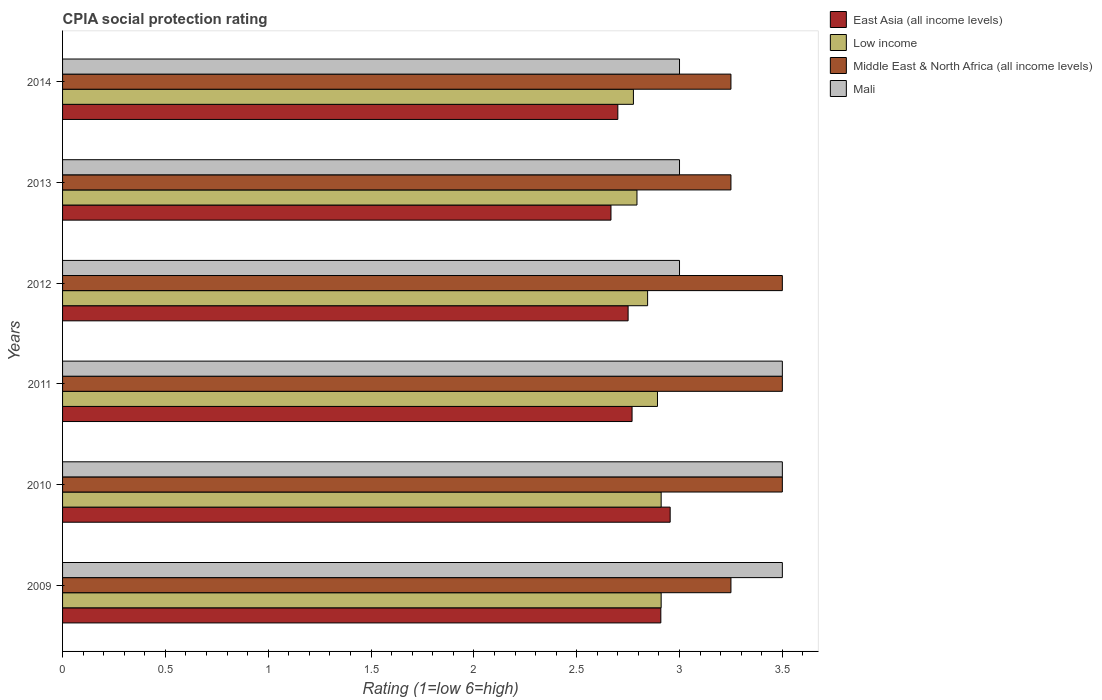How many bars are there on the 5th tick from the top?
Offer a very short reply. 4. How many bars are there on the 2nd tick from the bottom?
Offer a terse response. 4. What is the label of the 5th group of bars from the top?
Provide a short and direct response. 2010. What is the CPIA rating in Middle East & North Africa (all income levels) in 2012?
Provide a short and direct response. 3.5. Across all years, what is the maximum CPIA rating in Mali?
Provide a succinct answer. 3.5. Across all years, what is the minimum CPIA rating in Middle East & North Africa (all income levels)?
Ensure brevity in your answer.  3.25. In which year was the CPIA rating in East Asia (all income levels) maximum?
Provide a succinct answer. 2010. What is the total CPIA rating in Middle East & North Africa (all income levels) in the graph?
Your answer should be very brief. 20.25. What is the difference between the CPIA rating in Low income in 2013 and that in 2014?
Ensure brevity in your answer.  0.02. In the year 2011, what is the difference between the CPIA rating in East Asia (all income levels) and CPIA rating in Middle East & North Africa (all income levels)?
Your response must be concise. -0.73. What is the ratio of the CPIA rating in Middle East & North Africa (all income levels) in 2011 to that in 2013?
Your answer should be very brief. 1.08. Is the CPIA rating in Mali in 2010 less than that in 2013?
Provide a succinct answer. No. Is the difference between the CPIA rating in East Asia (all income levels) in 2010 and 2013 greater than the difference between the CPIA rating in Middle East & North Africa (all income levels) in 2010 and 2013?
Your answer should be very brief. Yes. What is the difference between the highest and the second highest CPIA rating in Mali?
Offer a terse response. 0. In how many years, is the CPIA rating in Low income greater than the average CPIA rating in Low income taken over all years?
Keep it short and to the point. 3. Is the sum of the CPIA rating in Low income in 2010 and 2014 greater than the maximum CPIA rating in Middle East & North Africa (all income levels) across all years?
Keep it short and to the point. Yes. Is it the case that in every year, the sum of the CPIA rating in Low income and CPIA rating in Middle East & North Africa (all income levels) is greater than the sum of CPIA rating in Mali and CPIA rating in East Asia (all income levels)?
Your answer should be compact. No. What does the 2nd bar from the top in 2010 represents?
Your answer should be very brief. Middle East & North Africa (all income levels). What does the 3rd bar from the bottom in 2009 represents?
Provide a succinct answer. Middle East & North Africa (all income levels). How many years are there in the graph?
Provide a succinct answer. 6. What is the difference between two consecutive major ticks on the X-axis?
Offer a very short reply. 0.5. Are the values on the major ticks of X-axis written in scientific E-notation?
Keep it short and to the point. No. Does the graph contain grids?
Your response must be concise. No. Where does the legend appear in the graph?
Offer a terse response. Top right. How are the legend labels stacked?
Offer a very short reply. Vertical. What is the title of the graph?
Provide a short and direct response. CPIA social protection rating. Does "Belgium" appear as one of the legend labels in the graph?
Ensure brevity in your answer.  No. What is the label or title of the X-axis?
Offer a terse response. Rating (1=low 6=high). What is the Rating (1=low 6=high) of East Asia (all income levels) in 2009?
Your answer should be compact. 2.91. What is the Rating (1=low 6=high) of Low income in 2009?
Ensure brevity in your answer.  2.91. What is the Rating (1=low 6=high) of East Asia (all income levels) in 2010?
Give a very brief answer. 2.95. What is the Rating (1=low 6=high) in Low income in 2010?
Your answer should be very brief. 2.91. What is the Rating (1=low 6=high) in Middle East & North Africa (all income levels) in 2010?
Provide a short and direct response. 3.5. What is the Rating (1=low 6=high) in Mali in 2010?
Provide a succinct answer. 3.5. What is the Rating (1=low 6=high) in East Asia (all income levels) in 2011?
Your answer should be very brief. 2.77. What is the Rating (1=low 6=high) in Low income in 2011?
Ensure brevity in your answer.  2.89. What is the Rating (1=low 6=high) of East Asia (all income levels) in 2012?
Give a very brief answer. 2.75. What is the Rating (1=low 6=high) of Low income in 2012?
Give a very brief answer. 2.84. What is the Rating (1=low 6=high) in East Asia (all income levels) in 2013?
Make the answer very short. 2.67. What is the Rating (1=low 6=high) of Low income in 2013?
Keep it short and to the point. 2.79. What is the Rating (1=low 6=high) of East Asia (all income levels) in 2014?
Offer a very short reply. 2.7. What is the Rating (1=low 6=high) in Low income in 2014?
Ensure brevity in your answer.  2.78. What is the Rating (1=low 6=high) of Middle East & North Africa (all income levels) in 2014?
Your response must be concise. 3.25. What is the Rating (1=low 6=high) in Mali in 2014?
Offer a terse response. 3. Across all years, what is the maximum Rating (1=low 6=high) of East Asia (all income levels)?
Provide a short and direct response. 2.95. Across all years, what is the maximum Rating (1=low 6=high) in Low income?
Your answer should be compact. 2.91. Across all years, what is the maximum Rating (1=low 6=high) in Mali?
Ensure brevity in your answer.  3.5. Across all years, what is the minimum Rating (1=low 6=high) of East Asia (all income levels)?
Provide a succinct answer. 2.67. Across all years, what is the minimum Rating (1=low 6=high) of Low income?
Your answer should be very brief. 2.78. What is the total Rating (1=low 6=high) of East Asia (all income levels) in the graph?
Keep it short and to the point. 16.75. What is the total Rating (1=low 6=high) in Low income in the graph?
Keep it short and to the point. 17.13. What is the total Rating (1=low 6=high) in Middle East & North Africa (all income levels) in the graph?
Your answer should be compact. 20.25. What is the difference between the Rating (1=low 6=high) in East Asia (all income levels) in 2009 and that in 2010?
Provide a short and direct response. -0.05. What is the difference between the Rating (1=low 6=high) of Low income in 2009 and that in 2010?
Offer a very short reply. 0. What is the difference between the Rating (1=low 6=high) in East Asia (all income levels) in 2009 and that in 2011?
Your answer should be very brief. 0.14. What is the difference between the Rating (1=low 6=high) of Low income in 2009 and that in 2011?
Ensure brevity in your answer.  0.02. What is the difference between the Rating (1=low 6=high) of East Asia (all income levels) in 2009 and that in 2012?
Provide a short and direct response. 0.16. What is the difference between the Rating (1=low 6=high) of Low income in 2009 and that in 2012?
Your answer should be very brief. 0.07. What is the difference between the Rating (1=low 6=high) of Mali in 2009 and that in 2012?
Offer a terse response. 0.5. What is the difference between the Rating (1=low 6=high) in East Asia (all income levels) in 2009 and that in 2013?
Keep it short and to the point. 0.24. What is the difference between the Rating (1=low 6=high) in Low income in 2009 and that in 2013?
Ensure brevity in your answer.  0.12. What is the difference between the Rating (1=low 6=high) in East Asia (all income levels) in 2009 and that in 2014?
Ensure brevity in your answer.  0.21. What is the difference between the Rating (1=low 6=high) in Low income in 2009 and that in 2014?
Your answer should be very brief. 0.13. What is the difference between the Rating (1=low 6=high) in Middle East & North Africa (all income levels) in 2009 and that in 2014?
Your answer should be very brief. 0. What is the difference between the Rating (1=low 6=high) of East Asia (all income levels) in 2010 and that in 2011?
Offer a terse response. 0.19. What is the difference between the Rating (1=low 6=high) in Low income in 2010 and that in 2011?
Keep it short and to the point. 0.02. What is the difference between the Rating (1=low 6=high) of East Asia (all income levels) in 2010 and that in 2012?
Give a very brief answer. 0.2. What is the difference between the Rating (1=low 6=high) in Low income in 2010 and that in 2012?
Your answer should be very brief. 0.07. What is the difference between the Rating (1=low 6=high) in Mali in 2010 and that in 2012?
Provide a short and direct response. 0.5. What is the difference between the Rating (1=low 6=high) in East Asia (all income levels) in 2010 and that in 2013?
Give a very brief answer. 0.29. What is the difference between the Rating (1=low 6=high) of Low income in 2010 and that in 2013?
Offer a terse response. 0.12. What is the difference between the Rating (1=low 6=high) of Mali in 2010 and that in 2013?
Give a very brief answer. 0.5. What is the difference between the Rating (1=low 6=high) of East Asia (all income levels) in 2010 and that in 2014?
Offer a very short reply. 0.25. What is the difference between the Rating (1=low 6=high) of Low income in 2010 and that in 2014?
Provide a short and direct response. 0.13. What is the difference between the Rating (1=low 6=high) in East Asia (all income levels) in 2011 and that in 2012?
Provide a succinct answer. 0.02. What is the difference between the Rating (1=low 6=high) of Low income in 2011 and that in 2012?
Your answer should be compact. 0.05. What is the difference between the Rating (1=low 6=high) of Middle East & North Africa (all income levels) in 2011 and that in 2012?
Offer a terse response. 0. What is the difference between the Rating (1=low 6=high) of East Asia (all income levels) in 2011 and that in 2013?
Provide a short and direct response. 0.1. What is the difference between the Rating (1=low 6=high) in Low income in 2011 and that in 2013?
Provide a short and direct response. 0.1. What is the difference between the Rating (1=low 6=high) in Mali in 2011 and that in 2013?
Your answer should be compact. 0.5. What is the difference between the Rating (1=low 6=high) of East Asia (all income levels) in 2011 and that in 2014?
Keep it short and to the point. 0.07. What is the difference between the Rating (1=low 6=high) of Low income in 2011 and that in 2014?
Provide a succinct answer. 0.12. What is the difference between the Rating (1=low 6=high) of East Asia (all income levels) in 2012 and that in 2013?
Make the answer very short. 0.08. What is the difference between the Rating (1=low 6=high) of Low income in 2012 and that in 2013?
Your answer should be very brief. 0.05. What is the difference between the Rating (1=low 6=high) in Middle East & North Africa (all income levels) in 2012 and that in 2013?
Offer a very short reply. 0.25. What is the difference between the Rating (1=low 6=high) in Mali in 2012 and that in 2013?
Your answer should be compact. 0. What is the difference between the Rating (1=low 6=high) of Low income in 2012 and that in 2014?
Your answer should be very brief. 0.07. What is the difference between the Rating (1=low 6=high) of Middle East & North Africa (all income levels) in 2012 and that in 2014?
Make the answer very short. 0.25. What is the difference between the Rating (1=low 6=high) in Mali in 2012 and that in 2014?
Ensure brevity in your answer.  0. What is the difference between the Rating (1=low 6=high) in East Asia (all income levels) in 2013 and that in 2014?
Keep it short and to the point. -0.03. What is the difference between the Rating (1=low 6=high) in Low income in 2013 and that in 2014?
Provide a succinct answer. 0.02. What is the difference between the Rating (1=low 6=high) of Mali in 2013 and that in 2014?
Provide a short and direct response. 0. What is the difference between the Rating (1=low 6=high) in East Asia (all income levels) in 2009 and the Rating (1=low 6=high) in Low income in 2010?
Your answer should be compact. -0. What is the difference between the Rating (1=low 6=high) in East Asia (all income levels) in 2009 and the Rating (1=low 6=high) in Middle East & North Africa (all income levels) in 2010?
Offer a terse response. -0.59. What is the difference between the Rating (1=low 6=high) in East Asia (all income levels) in 2009 and the Rating (1=low 6=high) in Mali in 2010?
Offer a very short reply. -0.59. What is the difference between the Rating (1=low 6=high) of Low income in 2009 and the Rating (1=low 6=high) of Middle East & North Africa (all income levels) in 2010?
Keep it short and to the point. -0.59. What is the difference between the Rating (1=low 6=high) of Low income in 2009 and the Rating (1=low 6=high) of Mali in 2010?
Ensure brevity in your answer.  -0.59. What is the difference between the Rating (1=low 6=high) in Middle East & North Africa (all income levels) in 2009 and the Rating (1=low 6=high) in Mali in 2010?
Provide a short and direct response. -0.25. What is the difference between the Rating (1=low 6=high) of East Asia (all income levels) in 2009 and the Rating (1=low 6=high) of Low income in 2011?
Give a very brief answer. 0.02. What is the difference between the Rating (1=low 6=high) in East Asia (all income levels) in 2009 and the Rating (1=low 6=high) in Middle East & North Africa (all income levels) in 2011?
Offer a terse response. -0.59. What is the difference between the Rating (1=low 6=high) in East Asia (all income levels) in 2009 and the Rating (1=low 6=high) in Mali in 2011?
Give a very brief answer. -0.59. What is the difference between the Rating (1=low 6=high) of Low income in 2009 and the Rating (1=low 6=high) of Middle East & North Africa (all income levels) in 2011?
Your answer should be compact. -0.59. What is the difference between the Rating (1=low 6=high) in Low income in 2009 and the Rating (1=low 6=high) in Mali in 2011?
Your answer should be very brief. -0.59. What is the difference between the Rating (1=low 6=high) of Middle East & North Africa (all income levels) in 2009 and the Rating (1=low 6=high) of Mali in 2011?
Provide a short and direct response. -0.25. What is the difference between the Rating (1=low 6=high) of East Asia (all income levels) in 2009 and the Rating (1=low 6=high) of Low income in 2012?
Your answer should be very brief. 0.06. What is the difference between the Rating (1=low 6=high) of East Asia (all income levels) in 2009 and the Rating (1=low 6=high) of Middle East & North Africa (all income levels) in 2012?
Your answer should be compact. -0.59. What is the difference between the Rating (1=low 6=high) of East Asia (all income levels) in 2009 and the Rating (1=low 6=high) of Mali in 2012?
Your answer should be compact. -0.09. What is the difference between the Rating (1=low 6=high) in Low income in 2009 and the Rating (1=low 6=high) in Middle East & North Africa (all income levels) in 2012?
Offer a very short reply. -0.59. What is the difference between the Rating (1=low 6=high) in Low income in 2009 and the Rating (1=low 6=high) in Mali in 2012?
Your response must be concise. -0.09. What is the difference between the Rating (1=low 6=high) in Middle East & North Africa (all income levels) in 2009 and the Rating (1=low 6=high) in Mali in 2012?
Give a very brief answer. 0.25. What is the difference between the Rating (1=low 6=high) of East Asia (all income levels) in 2009 and the Rating (1=low 6=high) of Low income in 2013?
Your answer should be compact. 0.12. What is the difference between the Rating (1=low 6=high) in East Asia (all income levels) in 2009 and the Rating (1=low 6=high) in Middle East & North Africa (all income levels) in 2013?
Keep it short and to the point. -0.34. What is the difference between the Rating (1=low 6=high) in East Asia (all income levels) in 2009 and the Rating (1=low 6=high) in Mali in 2013?
Offer a terse response. -0.09. What is the difference between the Rating (1=low 6=high) in Low income in 2009 and the Rating (1=low 6=high) in Middle East & North Africa (all income levels) in 2013?
Your response must be concise. -0.34. What is the difference between the Rating (1=low 6=high) in Low income in 2009 and the Rating (1=low 6=high) in Mali in 2013?
Make the answer very short. -0.09. What is the difference between the Rating (1=low 6=high) in Middle East & North Africa (all income levels) in 2009 and the Rating (1=low 6=high) in Mali in 2013?
Your answer should be compact. 0.25. What is the difference between the Rating (1=low 6=high) of East Asia (all income levels) in 2009 and the Rating (1=low 6=high) of Low income in 2014?
Offer a terse response. 0.13. What is the difference between the Rating (1=low 6=high) of East Asia (all income levels) in 2009 and the Rating (1=low 6=high) of Middle East & North Africa (all income levels) in 2014?
Your response must be concise. -0.34. What is the difference between the Rating (1=low 6=high) in East Asia (all income levels) in 2009 and the Rating (1=low 6=high) in Mali in 2014?
Your answer should be compact. -0.09. What is the difference between the Rating (1=low 6=high) of Low income in 2009 and the Rating (1=low 6=high) of Middle East & North Africa (all income levels) in 2014?
Your answer should be compact. -0.34. What is the difference between the Rating (1=low 6=high) in Low income in 2009 and the Rating (1=low 6=high) in Mali in 2014?
Provide a short and direct response. -0.09. What is the difference between the Rating (1=low 6=high) of East Asia (all income levels) in 2010 and the Rating (1=low 6=high) of Low income in 2011?
Your answer should be compact. 0.06. What is the difference between the Rating (1=low 6=high) of East Asia (all income levels) in 2010 and the Rating (1=low 6=high) of Middle East & North Africa (all income levels) in 2011?
Your answer should be compact. -0.55. What is the difference between the Rating (1=low 6=high) in East Asia (all income levels) in 2010 and the Rating (1=low 6=high) in Mali in 2011?
Provide a short and direct response. -0.55. What is the difference between the Rating (1=low 6=high) in Low income in 2010 and the Rating (1=low 6=high) in Middle East & North Africa (all income levels) in 2011?
Provide a succinct answer. -0.59. What is the difference between the Rating (1=low 6=high) in Low income in 2010 and the Rating (1=low 6=high) in Mali in 2011?
Your response must be concise. -0.59. What is the difference between the Rating (1=low 6=high) in Middle East & North Africa (all income levels) in 2010 and the Rating (1=low 6=high) in Mali in 2011?
Provide a short and direct response. 0. What is the difference between the Rating (1=low 6=high) of East Asia (all income levels) in 2010 and the Rating (1=low 6=high) of Low income in 2012?
Offer a terse response. 0.11. What is the difference between the Rating (1=low 6=high) in East Asia (all income levels) in 2010 and the Rating (1=low 6=high) in Middle East & North Africa (all income levels) in 2012?
Your answer should be compact. -0.55. What is the difference between the Rating (1=low 6=high) in East Asia (all income levels) in 2010 and the Rating (1=low 6=high) in Mali in 2012?
Provide a short and direct response. -0.05. What is the difference between the Rating (1=low 6=high) in Low income in 2010 and the Rating (1=low 6=high) in Middle East & North Africa (all income levels) in 2012?
Make the answer very short. -0.59. What is the difference between the Rating (1=low 6=high) of Low income in 2010 and the Rating (1=low 6=high) of Mali in 2012?
Your response must be concise. -0.09. What is the difference between the Rating (1=low 6=high) of Middle East & North Africa (all income levels) in 2010 and the Rating (1=low 6=high) of Mali in 2012?
Keep it short and to the point. 0.5. What is the difference between the Rating (1=low 6=high) in East Asia (all income levels) in 2010 and the Rating (1=low 6=high) in Low income in 2013?
Offer a terse response. 0.16. What is the difference between the Rating (1=low 6=high) of East Asia (all income levels) in 2010 and the Rating (1=low 6=high) of Middle East & North Africa (all income levels) in 2013?
Provide a succinct answer. -0.3. What is the difference between the Rating (1=low 6=high) in East Asia (all income levels) in 2010 and the Rating (1=low 6=high) in Mali in 2013?
Offer a terse response. -0.05. What is the difference between the Rating (1=low 6=high) in Low income in 2010 and the Rating (1=low 6=high) in Middle East & North Africa (all income levels) in 2013?
Your answer should be very brief. -0.34. What is the difference between the Rating (1=low 6=high) in Low income in 2010 and the Rating (1=low 6=high) in Mali in 2013?
Keep it short and to the point. -0.09. What is the difference between the Rating (1=low 6=high) in Middle East & North Africa (all income levels) in 2010 and the Rating (1=low 6=high) in Mali in 2013?
Your response must be concise. 0.5. What is the difference between the Rating (1=low 6=high) in East Asia (all income levels) in 2010 and the Rating (1=low 6=high) in Low income in 2014?
Provide a succinct answer. 0.18. What is the difference between the Rating (1=low 6=high) in East Asia (all income levels) in 2010 and the Rating (1=low 6=high) in Middle East & North Africa (all income levels) in 2014?
Your response must be concise. -0.3. What is the difference between the Rating (1=low 6=high) of East Asia (all income levels) in 2010 and the Rating (1=low 6=high) of Mali in 2014?
Provide a succinct answer. -0.05. What is the difference between the Rating (1=low 6=high) in Low income in 2010 and the Rating (1=low 6=high) in Middle East & North Africa (all income levels) in 2014?
Offer a very short reply. -0.34. What is the difference between the Rating (1=low 6=high) of Low income in 2010 and the Rating (1=low 6=high) of Mali in 2014?
Ensure brevity in your answer.  -0.09. What is the difference between the Rating (1=low 6=high) of Middle East & North Africa (all income levels) in 2010 and the Rating (1=low 6=high) of Mali in 2014?
Provide a short and direct response. 0.5. What is the difference between the Rating (1=low 6=high) in East Asia (all income levels) in 2011 and the Rating (1=low 6=high) in Low income in 2012?
Make the answer very short. -0.08. What is the difference between the Rating (1=low 6=high) in East Asia (all income levels) in 2011 and the Rating (1=low 6=high) in Middle East & North Africa (all income levels) in 2012?
Make the answer very short. -0.73. What is the difference between the Rating (1=low 6=high) of East Asia (all income levels) in 2011 and the Rating (1=low 6=high) of Mali in 2012?
Your answer should be compact. -0.23. What is the difference between the Rating (1=low 6=high) of Low income in 2011 and the Rating (1=low 6=high) of Middle East & North Africa (all income levels) in 2012?
Keep it short and to the point. -0.61. What is the difference between the Rating (1=low 6=high) in Low income in 2011 and the Rating (1=low 6=high) in Mali in 2012?
Your response must be concise. -0.11. What is the difference between the Rating (1=low 6=high) of East Asia (all income levels) in 2011 and the Rating (1=low 6=high) of Low income in 2013?
Give a very brief answer. -0.02. What is the difference between the Rating (1=low 6=high) of East Asia (all income levels) in 2011 and the Rating (1=low 6=high) of Middle East & North Africa (all income levels) in 2013?
Offer a terse response. -0.48. What is the difference between the Rating (1=low 6=high) in East Asia (all income levels) in 2011 and the Rating (1=low 6=high) in Mali in 2013?
Ensure brevity in your answer.  -0.23. What is the difference between the Rating (1=low 6=high) of Low income in 2011 and the Rating (1=low 6=high) of Middle East & North Africa (all income levels) in 2013?
Provide a succinct answer. -0.36. What is the difference between the Rating (1=low 6=high) of Low income in 2011 and the Rating (1=low 6=high) of Mali in 2013?
Keep it short and to the point. -0.11. What is the difference between the Rating (1=low 6=high) in Middle East & North Africa (all income levels) in 2011 and the Rating (1=low 6=high) in Mali in 2013?
Make the answer very short. 0.5. What is the difference between the Rating (1=low 6=high) of East Asia (all income levels) in 2011 and the Rating (1=low 6=high) of Low income in 2014?
Your answer should be very brief. -0.01. What is the difference between the Rating (1=low 6=high) in East Asia (all income levels) in 2011 and the Rating (1=low 6=high) in Middle East & North Africa (all income levels) in 2014?
Provide a short and direct response. -0.48. What is the difference between the Rating (1=low 6=high) in East Asia (all income levels) in 2011 and the Rating (1=low 6=high) in Mali in 2014?
Ensure brevity in your answer.  -0.23. What is the difference between the Rating (1=low 6=high) of Low income in 2011 and the Rating (1=low 6=high) of Middle East & North Africa (all income levels) in 2014?
Your answer should be very brief. -0.36. What is the difference between the Rating (1=low 6=high) in Low income in 2011 and the Rating (1=low 6=high) in Mali in 2014?
Your answer should be compact. -0.11. What is the difference between the Rating (1=low 6=high) of East Asia (all income levels) in 2012 and the Rating (1=low 6=high) of Low income in 2013?
Offer a very short reply. -0.04. What is the difference between the Rating (1=low 6=high) in East Asia (all income levels) in 2012 and the Rating (1=low 6=high) in Middle East & North Africa (all income levels) in 2013?
Provide a short and direct response. -0.5. What is the difference between the Rating (1=low 6=high) of Low income in 2012 and the Rating (1=low 6=high) of Middle East & North Africa (all income levels) in 2013?
Your answer should be compact. -0.41. What is the difference between the Rating (1=low 6=high) in Low income in 2012 and the Rating (1=low 6=high) in Mali in 2013?
Provide a succinct answer. -0.16. What is the difference between the Rating (1=low 6=high) in Middle East & North Africa (all income levels) in 2012 and the Rating (1=low 6=high) in Mali in 2013?
Give a very brief answer. 0.5. What is the difference between the Rating (1=low 6=high) of East Asia (all income levels) in 2012 and the Rating (1=low 6=high) of Low income in 2014?
Ensure brevity in your answer.  -0.03. What is the difference between the Rating (1=low 6=high) of East Asia (all income levels) in 2012 and the Rating (1=low 6=high) of Mali in 2014?
Your answer should be very brief. -0.25. What is the difference between the Rating (1=low 6=high) in Low income in 2012 and the Rating (1=low 6=high) in Middle East & North Africa (all income levels) in 2014?
Offer a very short reply. -0.41. What is the difference between the Rating (1=low 6=high) of Low income in 2012 and the Rating (1=low 6=high) of Mali in 2014?
Your answer should be compact. -0.16. What is the difference between the Rating (1=low 6=high) of Middle East & North Africa (all income levels) in 2012 and the Rating (1=low 6=high) of Mali in 2014?
Provide a succinct answer. 0.5. What is the difference between the Rating (1=low 6=high) of East Asia (all income levels) in 2013 and the Rating (1=low 6=high) of Low income in 2014?
Your answer should be very brief. -0.11. What is the difference between the Rating (1=low 6=high) of East Asia (all income levels) in 2013 and the Rating (1=low 6=high) of Middle East & North Africa (all income levels) in 2014?
Provide a succinct answer. -0.58. What is the difference between the Rating (1=low 6=high) in East Asia (all income levels) in 2013 and the Rating (1=low 6=high) in Mali in 2014?
Keep it short and to the point. -0.33. What is the difference between the Rating (1=low 6=high) in Low income in 2013 and the Rating (1=low 6=high) in Middle East & North Africa (all income levels) in 2014?
Offer a terse response. -0.46. What is the difference between the Rating (1=low 6=high) in Low income in 2013 and the Rating (1=low 6=high) in Mali in 2014?
Provide a short and direct response. -0.21. What is the difference between the Rating (1=low 6=high) in Middle East & North Africa (all income levels) in 2013 and the Rating (1=low 6=high) in Mali in 2014?
Ensure brevity in your answer.  0.25. What is the average Rating (1=low 6=high) of East Asia (all income levels) per year?
Keep it short and to the point. 2.79. What is the average Rating (1=low 6=high) of Low income per year?
Keep it short and to the point. 2.85. What is the average Rating (1=low 6=high) in Middle East & North Africa (all income levels) per year?
Offer a very short reply. 3.38. What is the average Rating (1=low 6=high) in Mali per year?
Your answer should be very brief. 3.25. In the year 2009, what is the difference between the Rating (1=low 6=high) of East Asia (all income levels) and Rating (1=low 6=high) of Low income?
Your answer should be compact. -0. In the year 2009, what is the difference between the Rating (1=low 6=high) in East Asia (all income levels) and Rating (1=low 6=high) in Middle East & North Africa (all income levels)?
Give a very brief answer. -0.34. In the year 2009, what is the difference between the Rating (1=low 6=high) of East Asia (all income levels) and Rating (1=low 6=high) of Mali?
Provide a short and direct response. -0.59. In the year 2009, what is the difference between the Rating (1=low 6=high) in Low income and Rating (1=low 6=high) in Middle East & North Africa (all income levels)?
Keep it short and to the point. -0.34. In the year 2009, what is the difference between the Rating (1=low 6=high) in Low income and Rating (1=low 6=high) in Mali?
Your answer should be very brief. -0.59. In the year 2010, what is the difference between the Rating (1=low 6=high) in East Asia (all income levels) and Rating (1=low 6=high) in Low income?
Make the answer very short. 0.04. In the year 2010, what is the difference between the Rating (1=low 6=high) of East Asia (all income levels) and Rating (1=low 6=high) of Middle East & North Africa (all income levels)?
Make the answer very short. -0.55. In the year 2010, what is the difference between the Rating (1=low 6=high) of East Asia (all income levels) and Rating (1=low 6=high) of Mali?
Ensure brevity in your answer.  -0.55. In the year 2010, what is the difference between the Rating (1=low 6=high) in Low income and Rating (1=low 6=high) in Middle East & North Africa (all income levels)?
Provide a succinct answer. -0.59. In the year 2010, what is the difference between the Rating (1=low 6=high) of Low income and Rating (1=low 6=high) of Mali?
Offer a terse response. -0.59. In the year 2011, what is the difference between the Rating (1=low 6=high) in East Asia (all income levels) and Rating (1=low 6=high) in Low income?
Your answer should be compact. -0.12. In the year 2011, what is the difference between the Rating (1=low 6=high) in East Asia (all income levels) and Rating (1=low 6=high) in Middle East & North Africa (all income levels)?
Provide a short and direct response. -0.73. In the year 2011, what is the difference between the Rating (1=low 6=high) of East Asia (all income levels) and Rating (1=low 6=high) of Mali?
Keep it short and to the point. -0.73. In the year 2011, what is the difference between the Rating (1=low 6=high) of Low income and Rating (1=low 6=high) of Middle East & North Africa (all income levels)?
Provide a short and direct response. -0.61. In the year 2011, what is the difference between the Rating (1=low 6=high) of Low income and Rating (1=low 6=high) of Mali?
Give a very brief answer. -0.61. In the year 2012, what is the difference between the Rating (1=low 6=high) of East Asia (all income levels) and Rating (1=low 6=high) of Low income?
Offer a very short reply. -0.09. In the year 2012, what is the difference between the Rating (1=low 6=high) of East Asia (all income levels) and Rating (1=low 6=high) of Middle East & North Africa (all income levels)?
Provide a succinct answer. -0.75. In the year 2012, what is the difference between the Rating (1=low 6=high) of East Asia (all income levels) and Rating (1=low 6=high) of Mali?
Your answer should be compact. -0.25. In the year 2012, what is the difference between the Rating (1=low 6=high) in Low income and Rating (1=low 6=high) in Middle East & North Africa (all income levels)?
Provide a short and direct response. -0.66. In the year 2012, what is the difference between the Rating (1=low 6=high) of Low income and Rating (1=low 6=high) of Mali?
Your answer should be very brief. -0.16. In the year 2013, what is the difference between the Rating (1=low 6=high) of East Asia (all income levels) and Rating (1=low 6=high) of Low income?
Your answer should be compact. -0.13. In the year 2013, what is the difference between the Rating (1=low 6=high) in East Asia (all income levels) and Rating (1=low 6=high) in Middle East & North Africa (all income levels)?
Offer a terse response. -0.58. In the year 2013, what is the difference between the Rating (1=low 6=high) in East Asia (all income levels) and Rating (1=low 6=high) in Mali?
Ensure brevity in your answer.  -0.33. In the year 2013, what is the difference between the Rating (1=low 6=high) of Low income and Rating (1=low 6=high) of Middle East & North Africa (all income levels)?
Your answer should be very brief. -0.46. In the year 2013, what is the difference between the Rating (1=low 6=high) in Low income and Rating (1=low 6=high) in Mali?
Provide a short and direct response. -0.21. In the year 2013, what is the difference between the Rating (1=low 6=high) of Middle East & North Africa (all income levels) and Rating (1=low 6=high) of Mali?
Provide a succinct answer. 0.25. In the year 2014, what is the difference between the Rating (1=low 6=high) in East Asia (all income levels) and Rating (1=low 6=high) in Low income?
Your response must be concise. -0.08. In the year 2014, what is the difference between the Rating (1=low 6=high) in East Asia (all income levels) and Rating (1=low 6=high) in Middle East & North Africa (all income levels)?
Your answer should be very brief. -0.55. In the year 2014, what is the difference between the Rating (1=low 6=high) in East Asia (all income levels) and Rating (1=low 6=high) in Mali?
Provide a short and direct response. -0.3. In the year 2014, what is the difference between the Rating (1=low 6=high) of Low income and Rating (1=low 6=high) of Middle East & North Africa (all income levels)?
Ensure brevity in your answer.  -0.47. In the year 2014, what is the difference between the Rating (1=low 6=high) in Low income and Rating (1=low 6=high) in Mali?
Make the answer very short. -0.22. What is the ratio of the Rating (1=low 6=high) of East Asia (all income levels) in 2009 to that in 2010?
Provide a succinct answer. 0.98. What is the ratio of the Rating (1=low 6=high) of Middle East & North Africa (all income levels) in 2009 to that in 2010?
Provide a short and direct response. 0.93. What is the ratio of the Rating (1=low 6=high) of Mali in 2009 to that in 2010?
Offer a very short reply. 1. What is the ratio of the Rating (1=low 6=high) in East Asia (all income levels) in 2009 to that in 2011?
Ensure brevity in your answer.  1.05. What is the ratio of the Rating (1=low 6=high) in Low income in 2009 to that in 2011?
Your answer should be compact. 1.01. What is the ratio of the Rating (1=low 6=high) of Middle East & North Africa (all income levels) in 2009 to that in 2011?
Your answer should be very brief. 0.93. What is the ratio of the Rating (1=low 6=high) in East Asia (all income levels) in 2009 to that in 2012?
Offer a very short reply. 1.06. What is the ratio of the Rating (1=low 6=high) in Low income in 2009 to that in 2012?
Keep it short and to the point. 1.02. What is the ratio of the Rating (1=low 6=high) of Mali in 2009 to that in 2012?
Your response must be concise. 1.17. What is the ratio of the Rating (1=low 6=high) of East Asia (all income levels) in 2009 to that in 2013?
Your answer should be very brief. 1.09. What is the ratio of the Rating (1=low 6=high) in Low income in 2009 to that in 2013?
Provide a succinct answer. 1.04. What is the ratio of the Rating (1=low 6=high) of Middle East & North Africa (all income levels) in 2009 to that in 2013?
Provide a short and direct response. 1. What is the ratio of the Rating (1=low 6=high) in East Asia (all income levels) in 2009 to that in 2014?
Offer a very short reply. 1.08. What is the ratio of the Rating (1=low 6=high) of Low income in 2009 to that in 2014?
Provide a short and direct response. 1.05. What is the ratio of the Rating (1=low 6=high) in East Asia (all income levels) in 2010 to that in 2011?
Ensure brevity in your answer.  1.07. What is the ratio of the Rating (1=low 6=high) in Low income in 2010 to that in 2011?
Keep it short and to the point. 1.01. What is the ratio of the Rating (1=low 6=high) of East Asia (all income levels) in 2010 to that in 2012?
Give a very brief answer. 1.07. What is the ratio of the Rating (1=low 6=high) of Low income in 2010 to that in 2012?
Your response must be concise. 1.02. What is the ratio of the Rating (1=low 6=high) of East Asia (all income levels) in 2010 to that in 2013?
Your answer should be very brief. 1.11. What is the ratio of the Rating (1=low 6=high) in Low income in 2010 to that in 2013?
Ensure brevity in your answer.  1.04. What is the ratio of the Rating (1=low 6=high) of Middle East & North Africa (all income levels) in 2010 to that in 2013?
Your answer should be very brief. 1.08. What is the ratio of the Rating (1=low 6=high) of East Asia (all income levels) in 2010 to that in 2014?
Provide a succinct answer. 1.09. What is the ratio of the Rating (1=low 6=high) of Low income in 2010 to that in 2014?
Provide a short and direct response. 1.05. What is the ratio of the Rating (1=low 6=high) in Mali in 2010 to that in 2014?
Offer a very short reply. 1.17. What is the ratio of the Rating (1=low 6=high) of Low income in 2011 to that in 2012?
Give a very brief answer. 1.02. What is the ratio of the Rating (1=low 6=high) of Mali in 2011 to that in 2012?
Give a very brief answer. 1.17. What is the ratio of the Rating (1=low 6=high) in Low income in 2011 to that in 2013?
Provide a short and direct response. 1.04. What is the ratio of the Rating (1=low 6=high) in Middle East & North Africa (all income levels) in 2011 to that in 2013?
Keep it short and to the point. 1.08. What is the ratio of the Rating (1=low 6=high) of Mali in 2011 to that in 2013?
Keep it short and to the point. 1.17. What is the ratio of the Rating (1=low 6=high) of East Asia (all income levels) in 2011 to that in 2014?
Provide a short and direct response. 1.03. What is the ratio of the Rating (1=low 6=high) of Low income in 2011 to that in 2014?
Make the answer very short. 1.04. What is the ratio of the Rating (1=low 6=high) of Middle East & North Africa (all income levels) in 2011 to that in 2014?
Make the answer very short. 1.08. What is the ratio of the Rating (1=low 6=high) of Mali in 2011 to that in 2014?
Your answer should be very brief. 1.17. What is the ratio of the Rating (1=low 6=high) in East Asia (all income levels) in 2012 to that in 2013?
Make the answer very short. 1.03. What is the ratio of the Rating (1=low 6=high) of Low income in 2012 to that in 2013?
Give a very brief answer. 1.02. What is the ratio of the Rating (1=low 6=high) of Middle East & North Africa (all income levels) in 2012 to that in 2013?
Your answer should be compact. 1.08. What is the ratio of the Rating (1=low 6=high) of East Asia (all income levels) in 2012 to that in 2014?
Keep it short and to the point. 1.02. What is the ratio of the Rating (1=low 6=high) in Low income in 2012 to that in 2014?
Keep it short and to the point. 1.02. What is the ratio of the Rating (1=low 6=high) of Low income in 2013 to that in 2014?
Make the answer very short. 1.01. What is the ratio of the Rating (1=low 6=high) of Middle East & North Africa (all income levels) in 2013 to that in 2014?
Offer a very short reply. 1. What is the ratio of the Rating (1=low 6=high) in Mali in 2013 to that in 2014?
Provide a short and direct response. 1. What is the difference between the highest and the second highest Rating (1=low 6=high) of East Asia (all income levels)?
Give a very brief answer. 0.05. What is the difference between the highest and the second highest Rating (1=low 6=high) in Middle East & North Africa (all income levels)?
Your answer should be compact. 0. What is the difference between the highest and the second highest Rating (1=low 6=high) in Mali?
Your answer should be compact. 0. What is the difference between the highest and the lowest Rating (1=low 6=high) in East Asia (all income levels)?
Offer a terse response. 0.29. What is the difference between the highest and the lowest Rating (1=low 6=high) of Low income?
Provide a succinct answer. 0.13. What is the difference between the highest and the lowest Rating (1=low 6=high) in Middle East & North Africa (all income levels)?
Provide a succinct answer. 0.25. What is the difference between the highest and the lowest Rating (1=low 6=high) in Mali?
Provide a short and direct response. 0.5. 